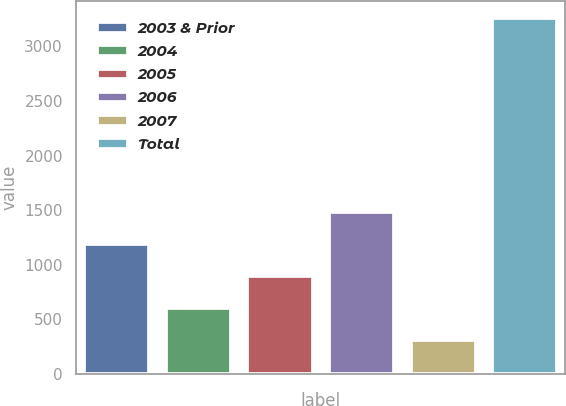Convert chart to OTSL. <chart><loc_0><loc_0><loc_500><loc_500><bar_chart><fcel>2003 & Prior<fcel>2004<fcel>2005<fcel>2006<fcel>2007<fcel>Total<nl><fcel>1190.6<fcel>600.2<fcel>895.4<fcel>1485.8<fcel>305<fcel>3257<nl></chart> 